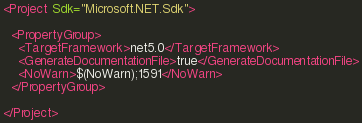<code> <loc_0><loc_0><loc_500><loc_500><_XML_><Project Sdk="Microsoft.NET.Sdk">

  <PropertyGroup>
    <TargetFramework>net5.0</TargetFramework>
    <GenerateDocumentationFile>true</GenerateDocumentationFile>
    <NoWarn>$(NoWarn);1591</NoWarn>
  </PropertyGroup>

</Project>
</code> 